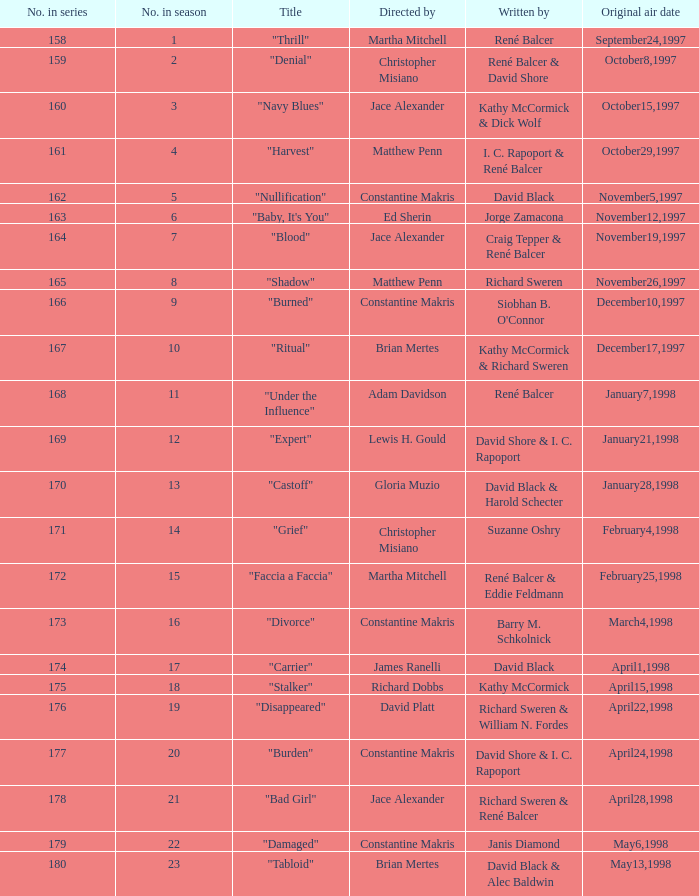Name the title of the episode that ed sherin directed. "Baby, It's You". 